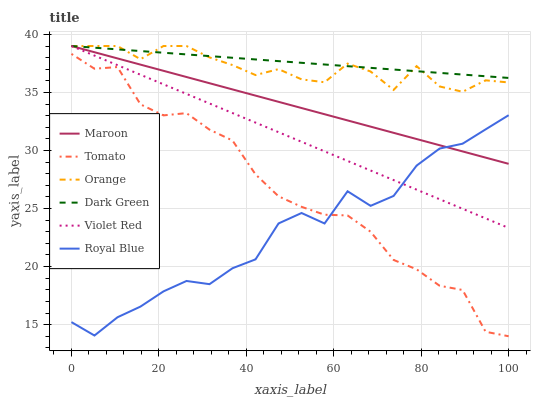Does Royal Blue have the minimum area under the curve?
Answer yes or no. Yes. Does Dark Green have the maximum area under the curve?
Answer yes or no. Yes. Does Violet Red have the minimum area under the curve?
Answer yes or no. No. Does Violet Red have the maximum area under the curve?
Answer yes or no. No. Is Dark Green the smoothest?
Answer yes or no. Yes. Is Royal Blue the roughest?
Answer yes or no. Yes. Is Violet Red the smoothest?
Answer yes or no. No. Is Violet Red the roughest?
Answer yes or no. No. Does Violet Red have the lowest value?
Answer yes or no. No. Does Royal Blue have the highest value?
Answer yes or no. No. Is Tomato less than Violet Red?
Answer yes or no. Yes. Is Orange greater than Royal Blue?
Answer yes or no. Yes. Does Tomato intersect Violet Red?
Answer yes or no. No. 